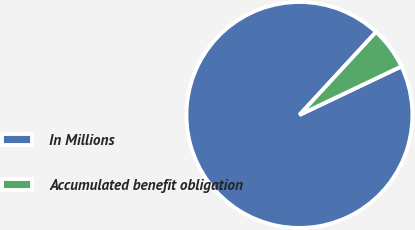<chart> <loc_0><loc_0><loc_500><loc_500><pie_chart><fcel>In Millions<fcel>Accumulated benefit obligation<nl><fcel>93.94%<fcel>6.06%<nl></chart> 